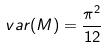<formula> <loc_0><loc_0><loc_500><loc_500>v a r ( M ) = \frac { \pi ^ { 2 } } { 1 2 }</formula> 